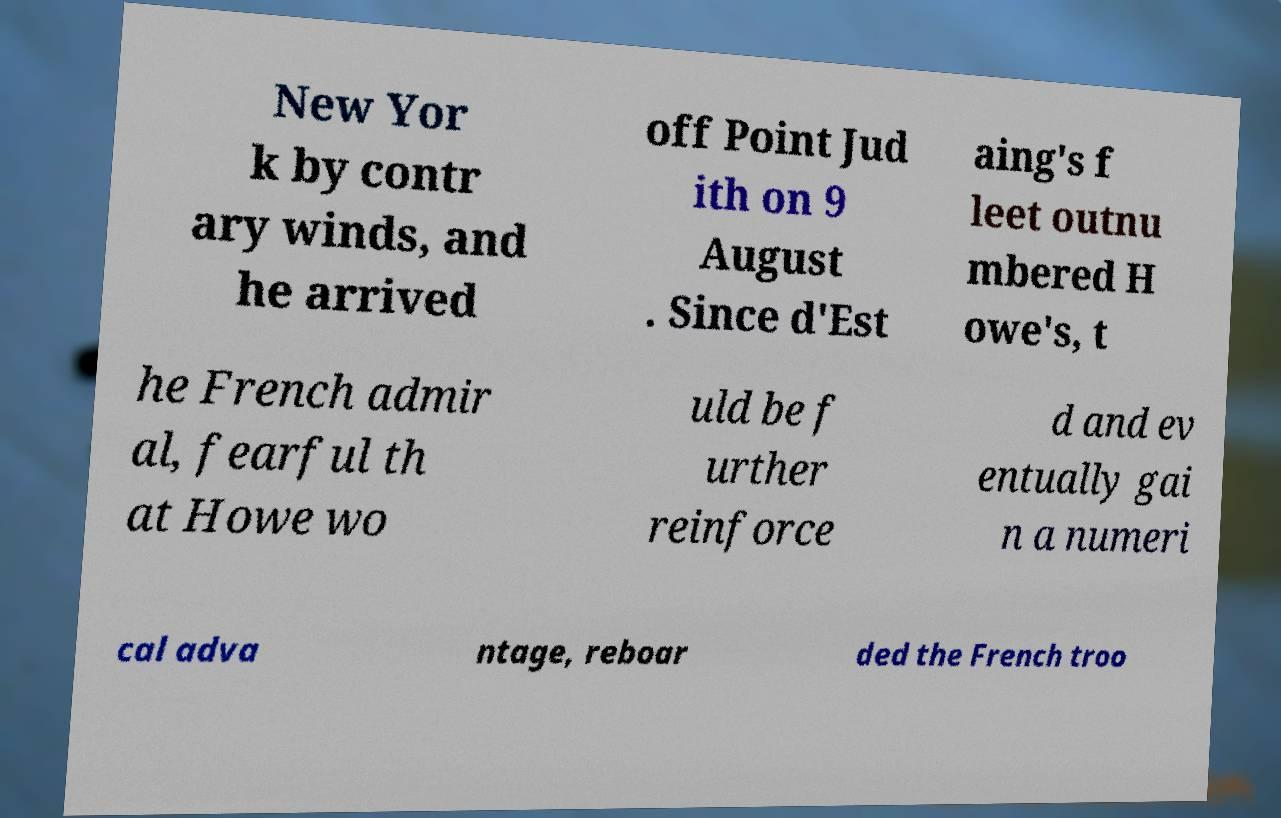Could you assist in decoding the text presented in this image and type it out clearly? New Yor k by contr ary winds, and he arrived off Point Jud ith on 9 August . Since d'Est aing's f leet outnu mbered H owe's, t he French admir al, fearful th at Howe wo uld be f urther reinforce d and ev entually gai n a numeri cal adva ntage, reboar ded the French troo 